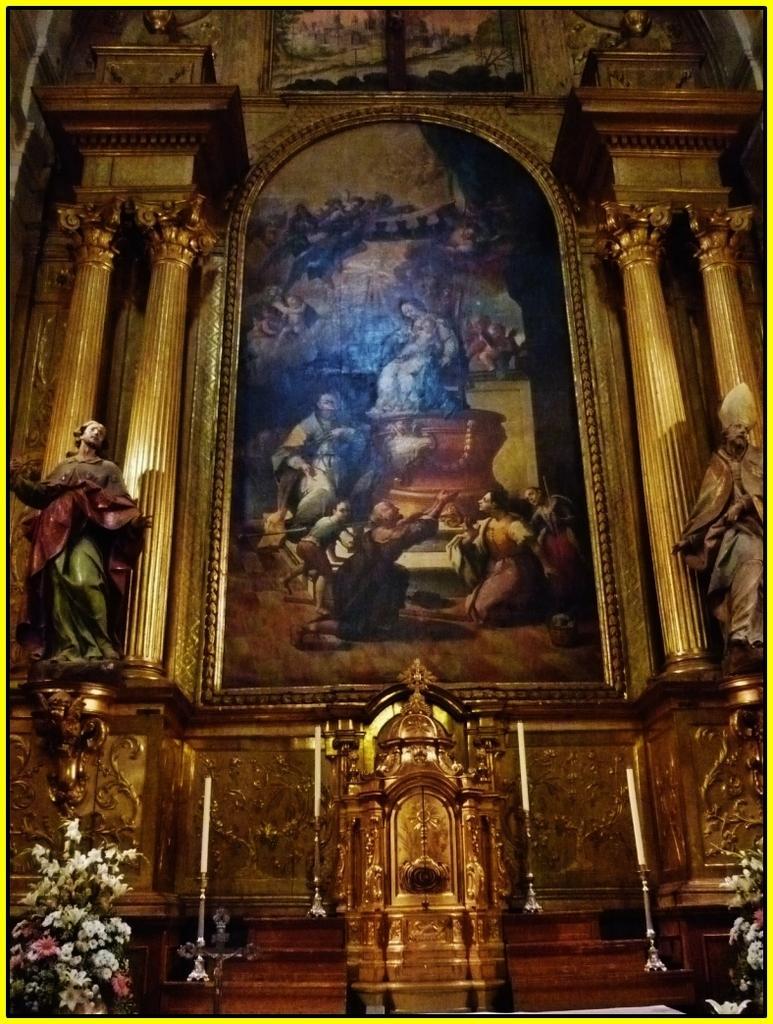Can you describe this image briefly? In this image we can see flower bouquets, statues, candles, pillars, and pictures. There is a designed wall. 